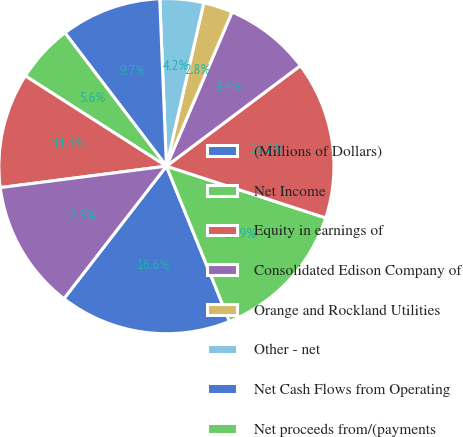Convert chart to OTSL. <chart><loc_0><loc_0><loc_500><loc_500><pie_chart><fcel>(Millions of Dollars)<fcel>Net Income<fcel>Equity in earnings of<fcel>Consolidated Edison Company of<fcel>Orange and Rockland Utilities<fcel>Other - net<fcel>Net Cash Flows from Operating<fcel>Net proceeds from/(payments<fcel>Common shares issued<fcel>Common stock dividends<nl><fcel>16.62%<fcel>13.86%<fcel>15.24%<fcel>8.35%<fcel>2.83%<fcel>4.21%<fcel>9.72%<fcel>5.59%<fcel>11.1%<fcel>12.48%<nl></chart> 